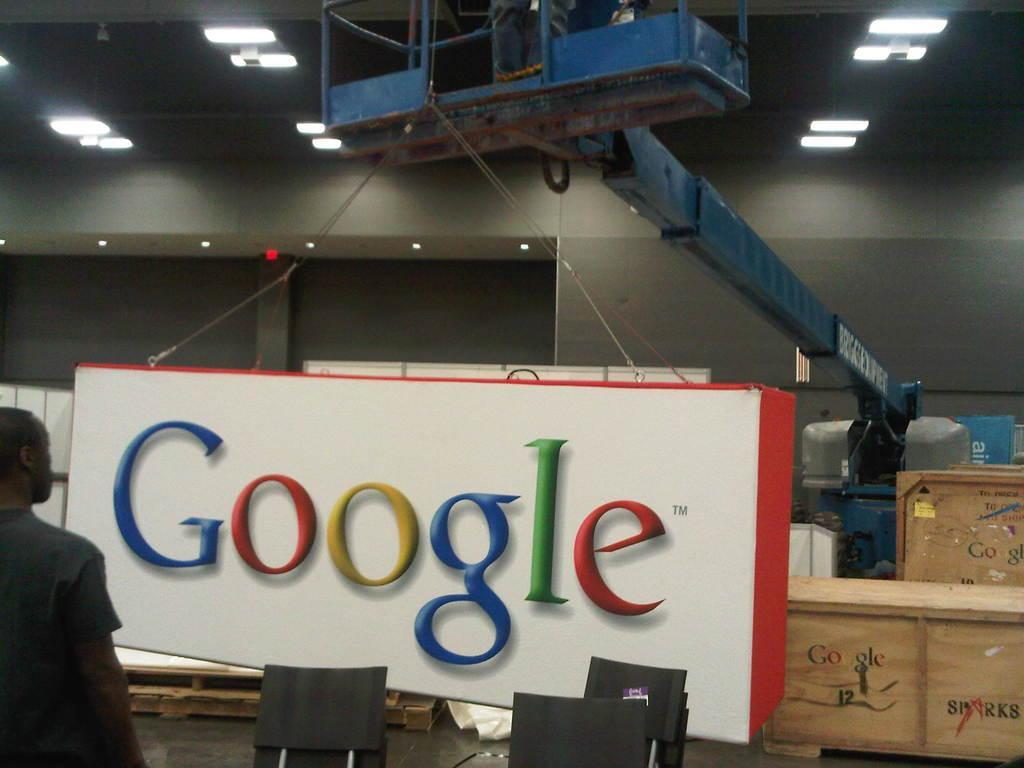Please provide a concise description of this image. In the image we can see there is a person who is standing, in front of him there is a banner on which its written "Google" and there are chairs and boxes kept on the table. On the top there are lighting and there is crane holding the banner. 